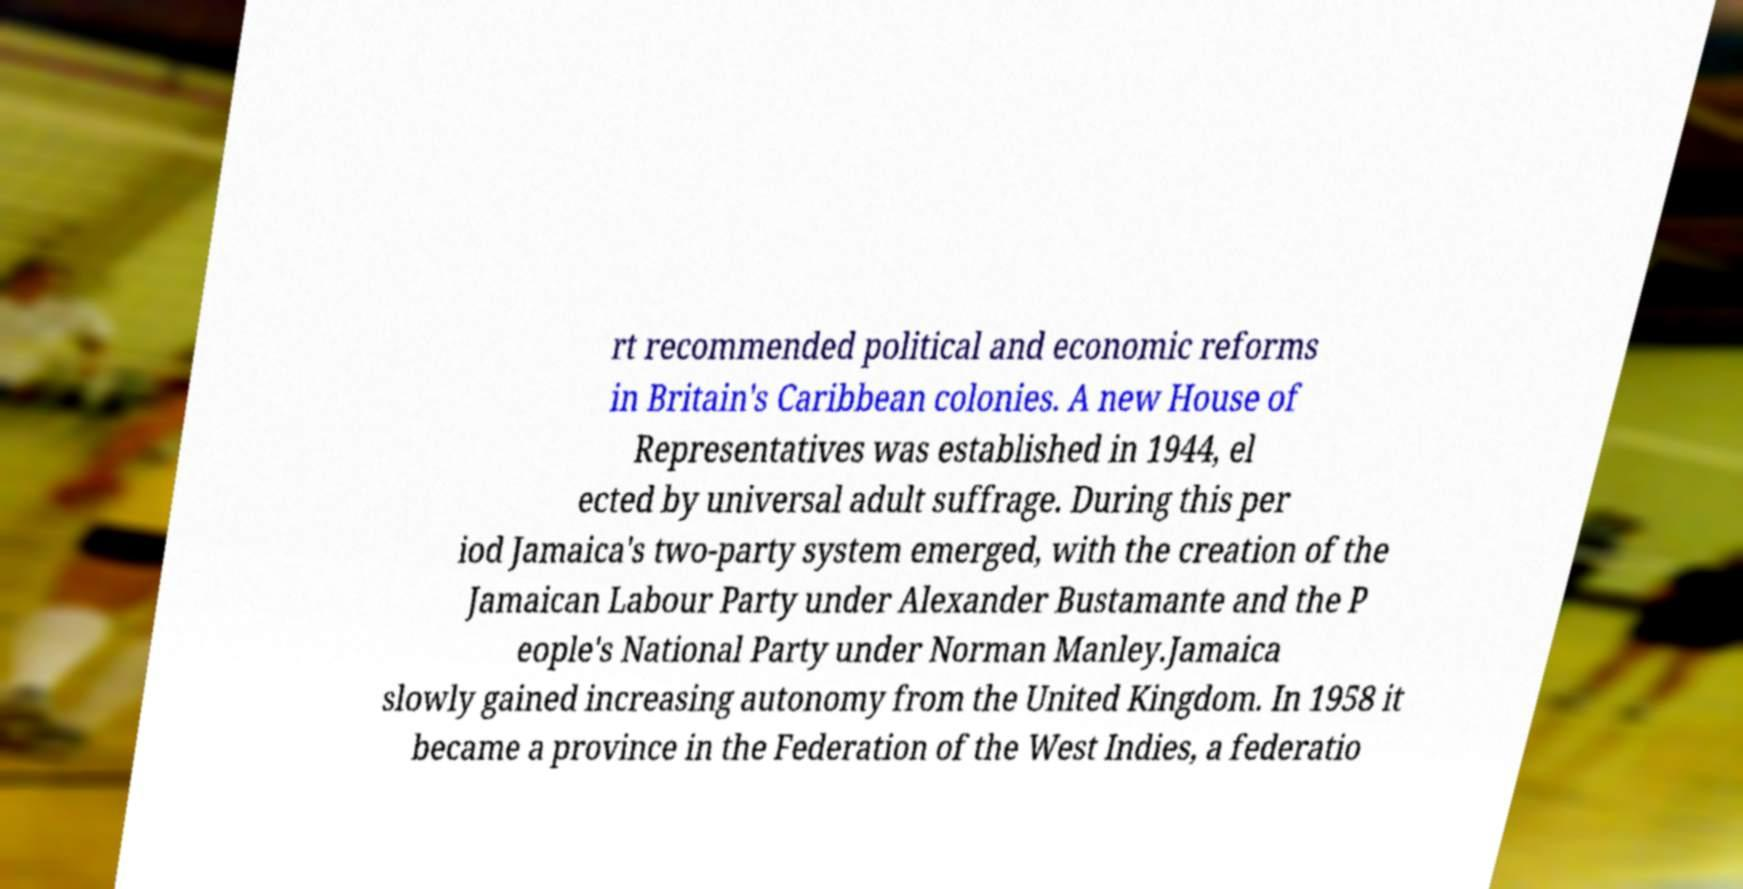I need the written content from this picture converted into text. Can you do that? rt recommended political and economic reforms in Britain's Caribbean colonies. A new House of Representatives was established in 1944, el ected by universal adult suffrage. During this per iod Jamaica's two-party system emerged, with the creation of the Jamaican Labour Party under Alexander Bustamante and the P eople's National Party under Norman Manley.Jamaica slowly gained increasing autonomy from the United Kingdom. In 1958 it became a province in the Federation of the West Indies, a federatio 